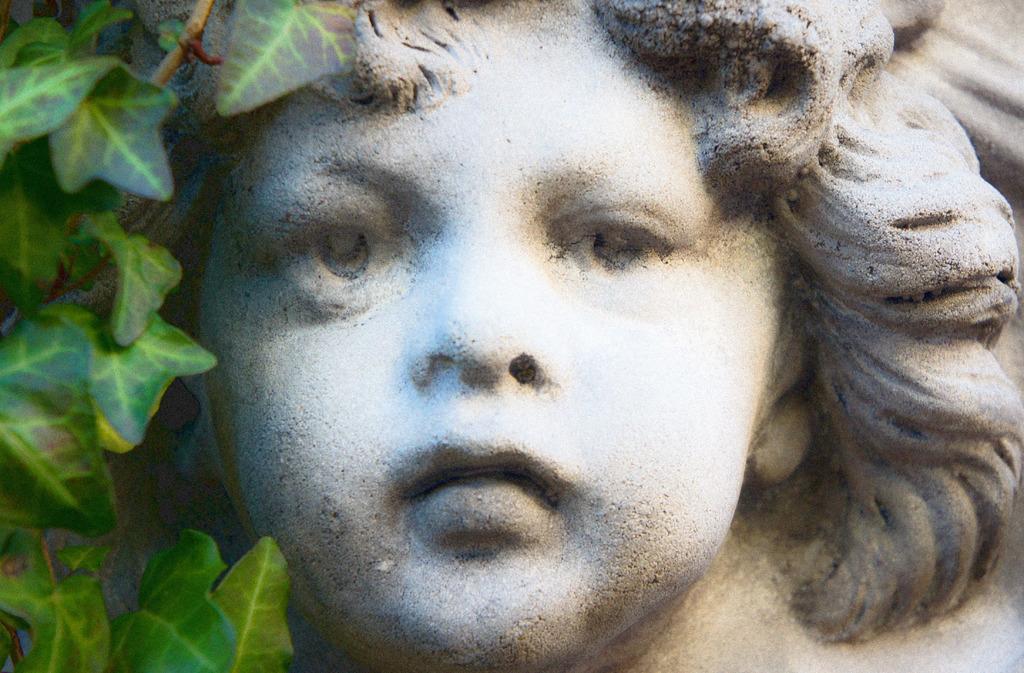Describe this image in one or two sentences. In this image I can see a person statue which is in white and black color. I can see few green leaves. 